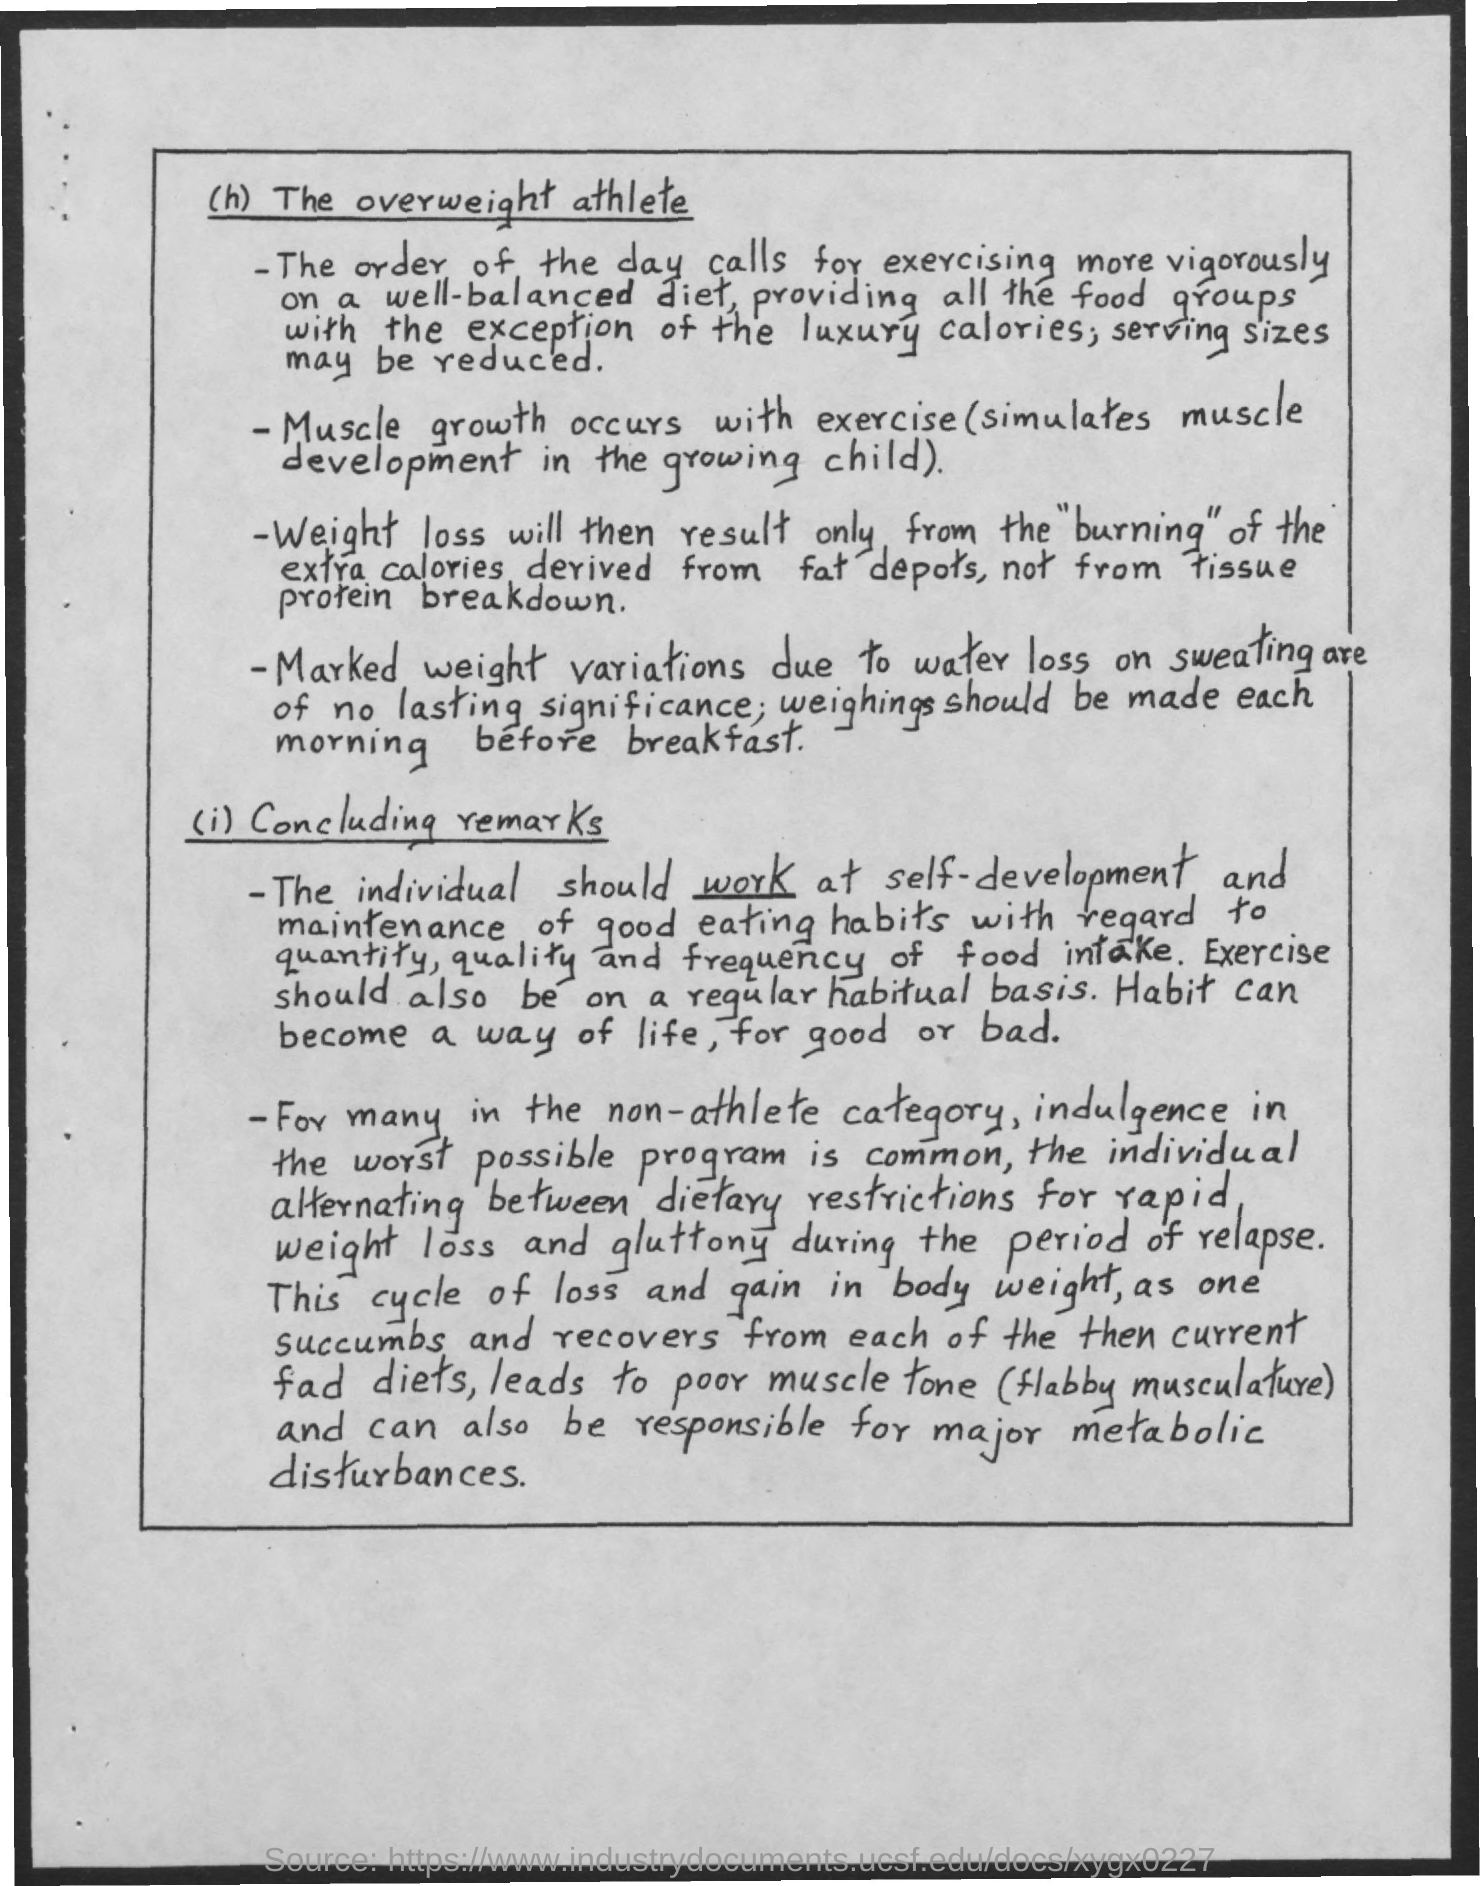Draw attention to some important aspects in this diagram. Regular exercise is essential for maintaining good health and overall well-being. 